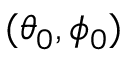Convert formula to latex. <formula><loc_0><loc_0><loc_500><loc_500>( \theta _ { 0 } , \phi _ { 0 } )</formula> 